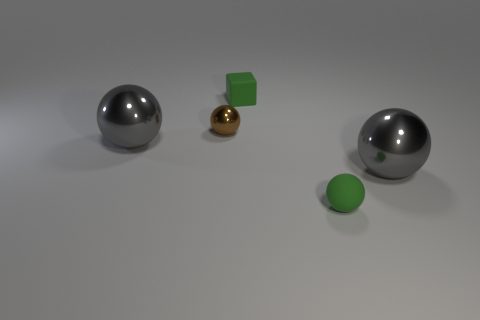What number of cyan shiny cylinders are the same size as the green rubber block?
Your response must be concise. 0. What number of shiny things are either tiny things or gray things?
Make the answer very short. 3. There is a tiny ball that is in front of the large gray sphere that is to the left of the rubber cube; what is it made of?
Offer a terse response. Rubber. What number of objects are small green cubes or small green things behind the small brown object?
Ensure brevity in your answer.  1. There is a green ball that is the same material as the tiny green cube; what size is it?
Provide a succinct answer. Small. What number of brown objects are small spheres or rubber balls?
Provide a succinct answer. 1. What is the shape of the matte object that is the same color as the tiny rubber ball?
Provide a short and direct response. Cube. Is there anything else that has the same material as the small green block?
Offer a very short reply. Yes. Is the shape of the object that is to the right of the small green rubber ball the same as the gray thing to the left of the small green matte ball?
Give a very brief answer. Yes. How many gray shiny spheres are there?
Your answer should be very brief. 2. 